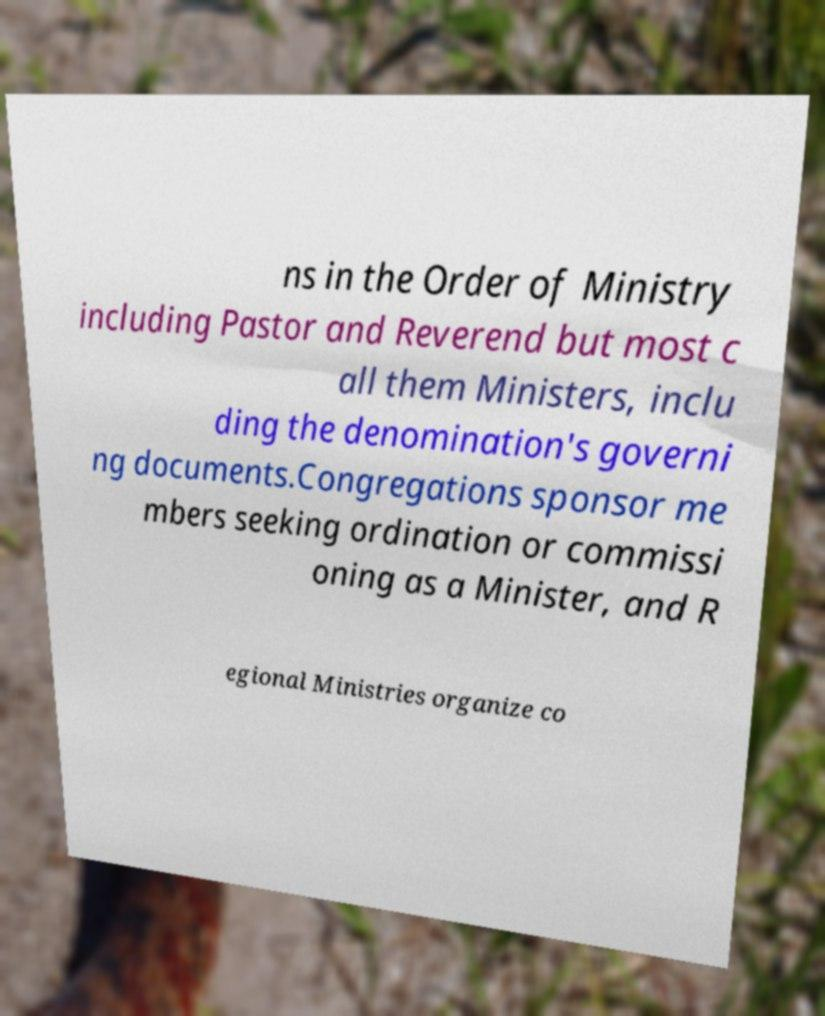I need the written content from this picture converted into text. Can you do that? ns in the Order of Ministry including Pastor and Reverend but most c all them Ministers, inclu ding the denomination's governi ng documents.Congregations sponsor me mbers seeking ordination or commissi oning as a Minister, and R egional Ministries organize co 